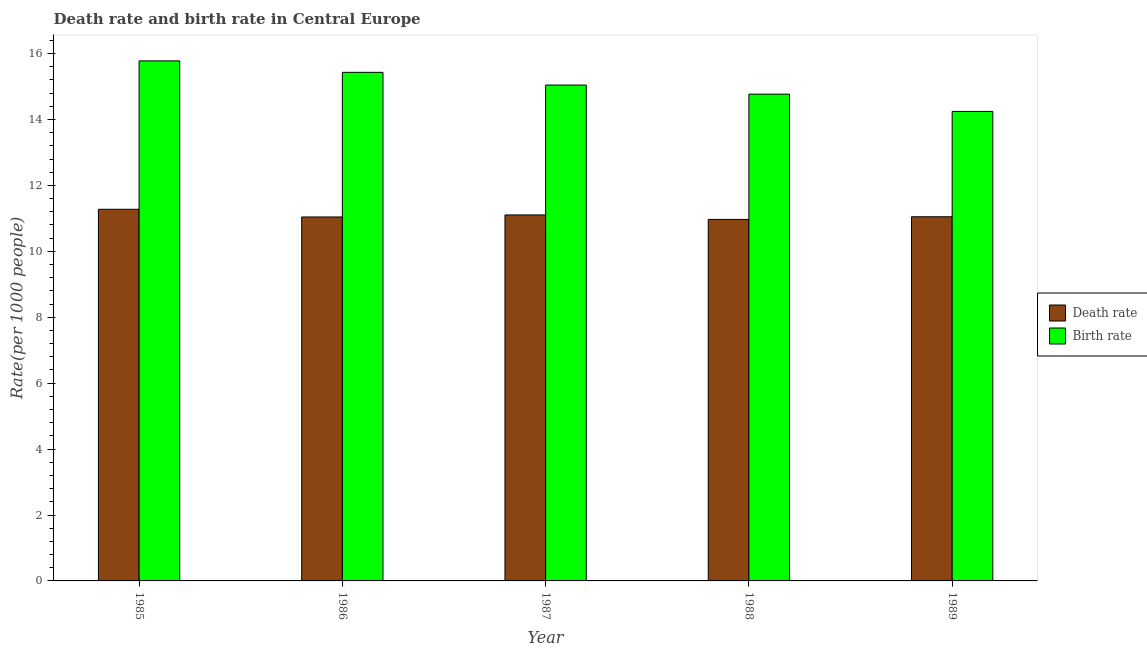How many different coloured bars are there?
Your answer should be very brief. 2. How many groups of bars are there?
Provide a short and direct response. 5. Are the number of bars per tick equal to the number of legend labels?
Your answer should be compact. Yes. How many bars are there on the 2nd tick from the right?
Keep it short and to the point. 2. In how many cases, is the number of bars for a given year not equal to the number of legend labels?
Offer a terse response. 0. What is the birth rate in 1988?
Offer a very short reply. 14.77. Across all years, what is the maximum birth rate?
Offer a terse response. 15.78. Across all years, what is the minimum birth rate?
Offer a very short reply. 14.25. In which year was the birth rate maximum?
Provide a succinct answer. 1985. In which year was the birth rate minimum?
Your answer should be compact. 1989. What is the total birth rate in the graph?
Give a very brief answer. 75.27. What is the difference between the death rate in 1985 and that in 1989?
Your response must be concise. 0.23. What is the difference between the death rate in 1985 and the birth rate in 1987?
Make the answer very short. 0.17. What is the average death rate per year?
Make the answer very short. 11.09. In the year 1985, what is the difference between the birth rate and death rate?
Ensure brevity in your answer.  0. What is the ratio of the death rate in 1987 to that in 1989?
Provide a short and direct response. 1.01. Is the birth rate in 1986 less than that in 1987?
Offer a terse response. No. Is the difference between the death rate in 1985 and 1989 greater than the difference between the birth rate in 1985 and 1989?
Offer a very short reply. No. What is the difference between the highest and the second highest death rate?
Make the answer very short. 0.17. What is the difference between the highest and the lowest birth rate?
Your answer should be compact. 1.53. In how many years, is the birth rate greater than the average birth rate taken over all years?
Offer a terse response. 2. Is the sum of the death rate in 1987 and 1988 greater than the maximum birth rate across all years?
Your answer should be very brief. Yes. What does the 2nd bar from the left in 1985 represents?
Your response must be concise. Birth rate. What does the 2nd bar from the right in 1986 represents?
Offer a very short reply. Death rate. How many years are there in the graph?
Your answer should be very brief. 5. What is the difference between two consecutive major ticks on the Y-axis?
Provide a succinct answer. 2. What is the title of the graph?
Your response must be concise. Death rate and birth rate in Central Europe. What is the label or title of the X-axis?
Your answer should be compact. Year. What is the label or title of the Y-axis?
Your response must be concise. Rate(per 1000 people). What is the Rate(per 1000 people) of Death rate in 1985?
Your answer should be very brief. 11.28. What is the Rate(per 1000 people) of Birth rate in 1985?
Keep it short and to the point. 15.78. What is the Rate(per 1000 people) in Death rate in 1986?
Keep it short and to the point. 11.04. What is the Rate(per 1000 people) of Birth rate in 1986?
Provide a succinct answer. 15.43. What is the Rate(per 1000 people) in Death rate in 1987?
Offer a terse response. 11.1. What is the Rate(per 1000 people) in Birth rate in 1987?
Make the answer very short. 15.05. What is the Rate(per 1000 people) in Death rate in 1988?
Ensure brevity in your answer.  10.97. What is the Rate(per 1000 people) of Birth rate in 1988?
Ensure brevity in your answer.  14.77. What is the Rate(per 1000 people) of Death rate in 1989?
Provide a succinct answer. 11.05. What is the Rate(per 1000 people) of Birth rate in 1989?
Keep it short and to the point. 14.25. Across all years, what is the maximum Rate(per 1000 people) of Death rate?
Offer a terse response. 11.28. Across all years, what is the maximum Rate(per 1000 people) of Birth rate?
Make the answer very short. 15.78. Across all years, what is the minimum Rate(per 1000 people) of Death rate?
Provide a short and direct response. 10.97. Across all years, what is the minimum Rate(per 1000 people) in Birth rate?
Offer a terse response. 14.25. What is the total Rate(per 1000 people) of Death rate in the graph?
Offer a terse response. 55.44. What is the total Rate(per 1000 people) in Birth rate in the graph?
Your response must be concise. 75.27. What is the difference between the Rate(per 1000 people) in Death rate in 1985 and that in 1986?
Provide a short and direct response. 0.23. What is the difference between the Rate(per 1000 people) of Birth rate in 1985 and that in 1986?
Give a very brief answer. 0.35. What is the difference between the Rate(per 1000 people) in Death rate in 1985 and that in 1987?
Your answer should be very brief. 0.17. What is the difference between the Rate(per 1000 people) of Birth rate in 1985 and that in 1987?
Keep it short and to the point. 0.73. What is the difference between the Rate(per 1000 people) of Death rate in 1985 and that in 1988?
Offer a very short reply. 0.31. What is the difference between the Rate(per 1000 people) in Birth rate in 1985 and that in 1988?
Keep it short and to the point. 1.01. What is the difference between the Rate(per 1000 people) of Death rate in 1985 and that in 1989?
Provide a short and direct response. 0.23. What is the difference between the Rate(per 1000 people) in Birth rate in 1985 and that in 1989?
Keep it short and to the point. 1.53. What is the difference between the Rate(per 1000 people) in Death rate in 1986 and that in 1987?
Provide a short and direct response. -0.06. What is the difference between the Rate(per 1000 people) in Birth rate in 1986 and that in 1987?
Offer a terse response. 0.39. What is the difference between the Rate(per 1000 people) of Death rate in 1986 and that in 1988?
Ensure brevity in your answer.  0.07. What is the difference between the Rate(per 1000 people) in Birth rate in 1986 and that in 1988?
Keep it short and to the point. 0.66. What is the difference between the Rate(per 1000 people) of Death rate in 1986 and that in 1989?
Your response must be concise. -0.01. What is the difference between the Rate(per 1000 people) in Birth rate in 1986 and that in 1989?
Provide a succinct answer. 1.19. What is the difference between the Rate(per 1000 people) of Death rate in 1987 and that in 1988?
Give a very brief answer. 0.14. What is the difference between the Rate(per 1000 people) in Birth rate in 1987 and that in 1988?
Offer a very short reply. 0.28. What is the difference between the Rate(per 1000 people) in Death rate in 1987 and that in 1989?
Offer a terse response. 0.06. What is the difference between the Rate(per 1000 people) of Birth rate in 1987 and that in 1989?
Provide a short and direct response. 0.8. What is the difference between the Rate(per 1000 people) of Death rate in 1988 and that in 1989?
Provide a short and direct response. -0.08. What is the difference between the Rate(per 1000 people) in Birth rate in 1988 and that in 1989?
Your answer should be compact. 0.52. What is the difference between the Rate(per 1000 people) of Death rate in 1985 and the Rate(per 1000 people) of Birth rate in 1986?
Make the answer very short. -4.15. What is the difference between the Rate(per 1000 people) of Death rate in 1985 and the Rate(per 1000 people) of Birth rate in 1987?
Your answer should be very brief. -3.77. What is the difference between the Rate(per 1000 people) in Death rate in 1985 and the Rate(per 1000 people) in Birth rate in 1988?
Your answer should be very brief. -3.49. What is the difference between the Rate(per 1000 people) of Death rate in 1985 and the Rate(per 1000 people) of Birth rate in 1989?
Give a very brief answer. -2.97. What is the difference between the Rate(per 1000 people) in Death rate in 1986 and the Rate(per 1000 people) in Birth rate in 1987?
Your answer should be compact. -4. What is the difference between the Rate(per 1000 people) in Death rate in 1986 and the Rate(per 1000 people) in Birth rate in 1988?
Give a very brief answer. -3.73. What is the difference between the Rate(per 1000 people) of Death rate in 1986 and the Rate(per 1000 people) of Birth rate in 1989?
Give a very brief answer. -3.2. What is the difference between the Rate(per 1000 people) of Death rate in 1987 and the Rate(per 1000 people) of Birth rate in 1988?
Your response must be concise. -3.67. What is the difference between the Rate(per 1000 people) in Death rate in 1987 and the Rate(per 1000 people) in Birth rate in 1989?
Offer a terse response. -3.14. What is the difference between the Rate(per 1000 people) of Death rate in 1988 and the Rate(per 1000 people) of Birth rate in 1989?
Ensure brevity in your answer.  -3.28. What is the average Rate(per 1000 people) of Death rate per year?
Make the answer very short. 11.09. What is the average Rate(per 1000 people) of Birth rate per year?
Your answer should be very brief. 15.05. In the year 1985, what is the difference between the Rate(per 1000 people) of Death rate and Rate(per 1000 people) of Birth rate?
Offer a very short reply. -4.5. In the year 1986, what is the difference between the Rate(per 1000 people) of Death rate and Rate(per 1000 people) of Birth rate?
Provide a succinct answer. -4.39. In the year 1987, what is the difference between the Rate(per 1000 people) of Death rate and Rate(per 1000 people) of Birth rate?
Your answer should be compact. -3.94. In the year 1988, what is the difference between the Rate(per 1000 people) of Death rate and Rate(per 1000 people) of Birth rate?
Provide a short and direct response. -3.8. In the year 1989, what is the difference between the Rate(per 1000 people) in Death rate and Rate(per 1000 people) in Birth rate?
Your answer should be very brief. -3.2. What is the ratio of the Rate(per 1000 people) in Death rate in 1985 to that in 1986?
Offer a very short reply. 1.02. What is the ratio of the Rate(per 1000 people) of Birth rate in 1985 to that in 1986?
Keep it short and to the point. 1.02. What is the ratio of the Rate(per 1000 people) in Death rate in 1985 to that in 1987?
Give a very brief answer. 1.02. What is the ratio of the Rate(per 1000 people) of Birth rate in 1985 to that in 1987?
Your answer should be compact. 1.05. What is the ratio of the Rate(per 1000 people) in Death rate in 1985 to that in 1988?
Your answer should be very brief. 1.03. What is the ratio of the Rate(per 1000 people) in Birth rate in 1985 to that in 1988?
Keep it short and to the point. 1.07. What is the ratio of the Rate(per 1000 people) in Death rate in 1985 to that in 1989?
Make the answer very short. 1.02. What is the ratio of the Rate(per 1000 people) in Birth rate in 1985 to that in 1989?
Your response must be concise. 1.11. What is the ratio of the Rate(per 1000 people) in Birth rate in 1986 to that in 1987?
Keep it short and to the point. 1.03. What is the ratio of the Rate(per 1000 people) of Death rate in 1986 to that in 1988?
Your answer should be compact. 1.01. What is the ratio of the Rate(per 1000 people) in Birth rate in 1986 to that in 1988?
Your answer should be compact. 1.04. What is the ratio of the Rate(per 1000 people) of Birth rate in 1986 to that in 1989?
Ensure brevity in your answer.  1.08. What is the ratio of the Rate(per 1000 people) in Death rate in 1987 to that in 1988?
Offer a very short reply. 1.01. What is the ratio of the Rate(per 1000 people) of Birth rate in 1987 to that in 1988?
Offer a terse response. 1.02. What is the ratio of the Rate(per 1000 people) of Death rate in 1987 to that in 1989?
Make the answer very short. 1. What is the ratio of the Rate(per 1000 people) of Birth rate in 1987 to that in 1989?
Offer a terse response. 1.06. What is the ratio of the Rate(per 1000 people) in Birth rate in 1988 to that in 1989?
Offer a very short reply. 1.04. What is the difference between the highest and the second highest Rate(per 1000 people) in Death rate?
Keep it short and to the point. 0.17. What is the difference between the highest and the second highest Rate(per 1000 people) in Birth rate?
Your response must be concise. 0.35. What is the difference between the highest and the lowest Rate(per 1000 people) in Death rate?
Make the answer very short. 0.31. What is the difference between the highest and the lowest Rate(per 1000 people) in Birth rate?
Make the answer very short. 1.53. 